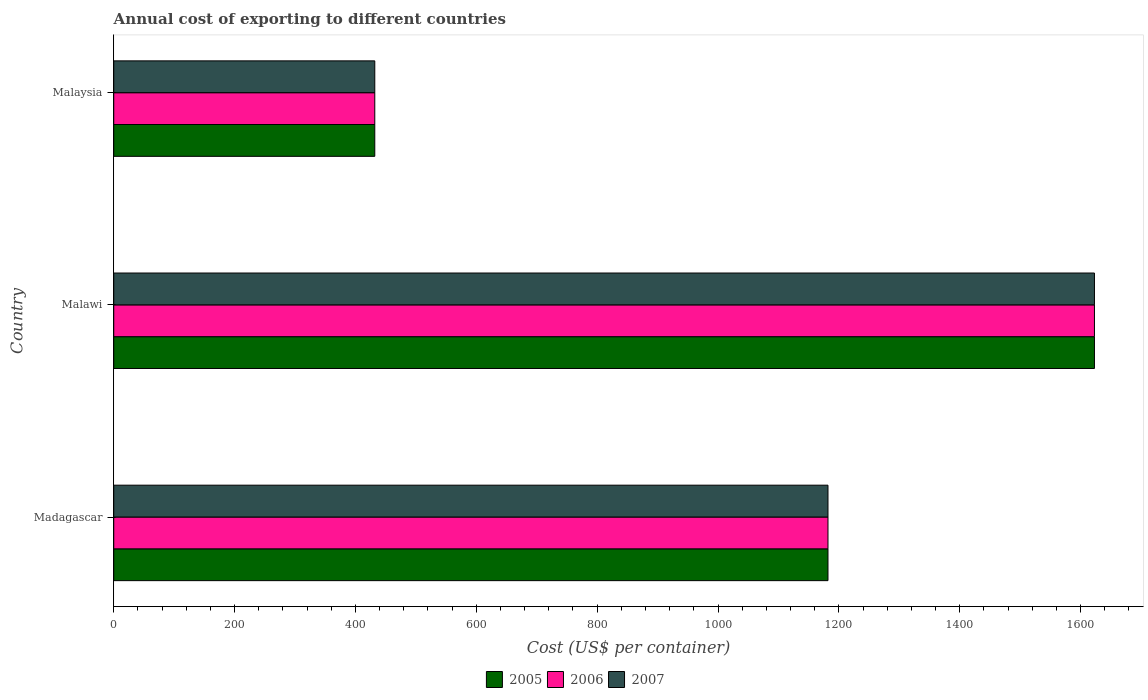How many different coloured bars are there?
Your answer should be compact. 3. Are the number of bars on each tick of the Y-axis equal?
Keep it short and to the point. Yes. How many bars are there on the 2nd tick from the bottom?
Ensure brevity in your answer.  3. What is the label of the 1st group of bars from the top?
Provide a succinct answer. Malaysia. In how many cases, is the number of bars for a given country not equal to the number of legend labels?
Your answer should be very brief. 0. What is the total annual cost of exporting in 2007 in Malaysia?
Make the answer very short. 432. Across all countries, what is the maximum total annual cost of exporting in 2006?
Make the answer very short. 1623. Across all countries, what is the minimum total annual cost of exporting in 2005?
Offer a very short reply. 432. In which country was the total annual cost of exporting in 2005 maximum?
Keep it short and to the point. Malawi. In which country was the total annual cost of exporting in 2005 minimum?
Provide a succinct answer. Malaysia. What is the total total annual cost of exporting in 2006 in the graph?
Ensure brevity in your answer.  3237. What is the difference between the total annual cost of exporting in 2005 in Madagascar and that in Malaysia?
Your answer should be very brief. 750. What is the difference between the total annual cost of exporting in 2007 in Malawi and the total annual cost of exporting in 2006 in Madagascar?
Your response must be concise. 441. What is the average total annual cost of exporting in 2007 per country?
Ensure brevity in your answer.  1079. In how many countries, is the total annual cost of exporting in 2006 greater than 80 US$?
Offer a terse response. 3. What is the ratio of the total annual cost of exporting in 2007 in Madagascar to that in Malaysia?
Give a very brief answer. 2.74. What is the difference between the highest and the second highest total annual cost of exporting in 2005?
Provide a short and direct response. 441. What is the difference between the highest and the lowest total annual cost of exporting in 2006?
Ensure brevity in your answer.  1191. In how many countries, is the total annual cost of exporting in 2006 greater than the average total annual cost of exporting in 2006 taken over all countries?
Provide a succinct answer. 2. What does the 2nd bar from the top in Madagascar represents?
Offer a terse response. 2006. What does the 1st bar from the bottom in Malaysia represents?
Provide a succinct answer. 2005. Are all the bars in the graph horizontal?
Give a very brief answer. Yes. What is the difference between two consecutive major ticks on the X-axis?
Ensure brevity in your answer.  200. Does the graph contain any zero values?
Keep it short and to the point. No. Does the graph contain grids?
Provide a short and direct response. No. Where does the legend appear in the graph?
Give a very brief answer. Bottom center. How are the legend labels stacked?
Your answer should be very brief. Horizontal. What is the title of the graph?
Give a very brief answer. Annual cost of exporting to different countries. Does "1984" appear as one of the legend labels in the graph?
Offer a very short reply. No. What is the label or title of the X-axis?
Give a very brief answer. Cost (US$ per container). What is the label or title of the Y-axis?
Keep it short and to the point. Country. What is the Cost (US$ per container) of 2005 in Madagascar?
Provide a succinct answer. 1182. What is the Cost (US$ per container) in 2006 in Madagascar?
Offer a terse response. 1182. What is the Cost (US$ per container) of 2007 in Madagascar?
Keep it short and to the point. 1182. What is the Cost (US$ per container) of 2005 in Malawi?
Offer a very short reply. 1623. What is the Cost (US$ per container) in 2006 in Malawi?
Keep it short and to the point. 1623. What is the Cost (US$ per container) in 2007 in Malawi?
Offer a terse response. 1623. What is the Cost (US$ per container) in 2005 in Malaysia?
Provide a short and direct response. 432. What is the Cost (US$ per container) of 2006 in Malaysia?
Give a very brief answer. 432. What is the Cost (US$ per container) of 2007 in Malaysia?
Ensure brevity in your answer.  432. Across all countries, what is the maximum Cost (US$ per container) in 2005?
Your answer should be compact. 1623. Across all countries, what is the maximum Cost (US$ per container) in 2006?
Give a very brief answer. 1623. Across all countries, what is the maximum Cost (US$ per container) of 2007?
Provide a short and direct response. 1623. Across all countries, what is the minimum Cost (US$ per container) in 2005?
Make the answer very short. 432. Across all countries, what is the minimum Cost (US$ per container) of 2006?
Your answer should be very brief. 432. Across all countries, what is the minimum Cost (US$ per container) of 2007?
Ensure brevity in your answer.  432. What is the total Cost (US$ per container) in 2005 in the graph?
Give a very brief answer. 3237. What is the total Cost (US$ per container) in 2006 in the graph?
Ensure brevity in your answer.  3237. What is the total Cost (US$ per container) in 2007 in the graph?
Provide a short and direct response. 3237. What is the difference between the Cost (US$ per container) in 2005 in Madagascar and that in Malawi?
Offer a terse response. -441. What is the difference between the Cost (US$ per container) of 2006 in Madagascar and that in Malawi?
Provide a succinct answer. -441. What is the difference between the Cost (US$ per container) of 2007 in Madagascar and that in Malawi?
Provide a short and direct response. -441. What is the difference between the Cost (US$ per container) of 2005 in Madagascar and that in Malaysia?
Your response must be concise. 750. What is the difference between the Cost (US$ per container) in 2006 in Madagascar and that in Malaysia?
Provide a succinct answer. 750. What is the difference between the Cost (US$ per container) of 2007 in Madagascar and that in Malaysia?
Offer a terse response. 750. What is the difference between the Cost (US$ per container) of 2005 in Malawi and that in Malaysia?
Offer a terse response. 1191. What is the difference between the Cost (US$ per container) in 2006 in Malawi and that in Malaysia?
Offer a very short reply. 1191. What is the difference between the Cost (US$ per container) of 2007 in Malawi and that in Malaysia?
Give a very brief answer. 1191. What is the difference between the Cost (US$ per container) in 2005 in Madagascar and the Cost (US$ per container) in 2006 in Malawi?
Keep it short and to the point. -441. What is the difference between the Cost (US$ per container) in 2005 in Madagascar and the Cost (US$ per container) in 2007 in Malawi?
Give a very brief answer. -441. What is the difference between the Cost (US$ per container) of 2006 in Madagascar and the Cost (US$ per container) of 2007 in Malawi?
Make the answer very short. -441. What is the difference between the Cost (US$ per container) of 2005 in Madagascar and the Cost (US$ per container) of 2006 in Malaysia?
Keep it short and to the point. 750. What is the difference between the Cost (US$ per container) of 2005 in Madagascar and the Cost (US$ per container) of 2007 in Malaysia?
Your response must be concise. 750. What is the difference between the Cost (US$ per container) of 2006 in Madagascar and the Cost (US$ per container) of 2007 in Malaysia?
Offer a terse response. 750. What is the difference between the Cost (US$ per container) of 2005 in Malawi and the Cost (US$ per container) of 2006 in Malaysia?
Ensure brevity in your answer.  1191. What is the difference between the Cost (US$ per container) in 2005 in Malawi and the Cost (US$ per container) in 2007 in Malaysia?
Offer a very short reply. 1191. What is the difference between the Cost (US$ per container) in 2006 in Malawi and the Cost (US$ per container) in 2007 in Malaysia?
Give a very brief answer. 1191. What is the average Cost (US$ per container) of 2005 per country?
Give a very brief answer. 1079. What is the average Cost (US$ per container) in 2006 per country?
Offer a very short reply. 1079. What is the average Cost (US$ per container) in 2007 per country?
Keep it short and to the point. 1079. What is the difference between the Cost (US$ per container) in 2005 and Cost (US$ per container) in 2006 in Madagascar?
Your response must be concise. 0. What is the difference between the Cost (US$ per container) of 2005 and Cost (US$ per container) of 2006 in Malawi?
Keep it short and to the point. 0. What is the difference between the Cost (US$ per container) in 2005 and Cost (US$ per container) in 2007 in Malawi?
Provide a short and direct response. 0. What is the ratio of the Cost (US$ per container) in 2005 in Madagascar to that in Malawi?
Offer a very short reply. 0.73. What is the ratio of the Cost (US$ per container) of 2006 in Madagascar to that in Malawi?
Offer a very short reply. 0.73. What is the ratio of the Cost (US$ per container) in 2007 in Madagascar to that in Malawi?
Provide a short and direct response. 0.73. What is the ratio of the Cost (US$ per container) in 2005 in Madagascar to that in Malaysia?
Your response must be concise. 2.74. What is the ratio of the Cost (US$ per container) of 2006 in Madagascar to that in Malaysia?
Offer a terse response. 2.74. What is the ratio of the Cost (US$ per container) in 2007 in Madagascar to that in Malaysia?
Ensure brevity in your answer.  2.74. What is the ratio of the Cost (US$ per container) in 2005 in Malawi to that in Malaysia?
Your response must be concise. 3.76. What is the ratio of the Cost (US$ per container) of 2006 in Malawi to that in Malaysia?
Provide a succinct answer. 3.76. What is the ratio of the Cost (US$ per container) of 2007 in Malawi to that in Malaysia?
Offer a terse response. 3.76. What is the difference between the highest and the second highest Cost (US$ per container) in 2005?
Offer a terse response. 441. What is the difference between the highest and the second highest Cost (US$ per container) of 2006?
Provide a short and direct response. 441. What is the difference between the highest and the second highest Cost (US$ per container) of 2007?
Keep it short and to the point. 441. What is the difference between the highest and the lowest Cost (US$ per container) of 2005?
Ensure brevity in your answer.  1191. What is the difference between the highest and the lowest Cost (US$ per container) of 2006?
Offer a very short reply. 1191. What is the difference between the highest and the lowest Cost (US$ per container) in 2007?
Offer a terse response. 1191. 